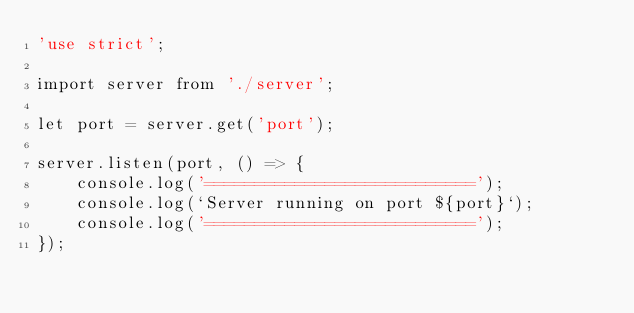Convert code to text. <code><loc_0><loc_0><loc_500><loc_500><_JavaScript_>'use strict';

import server from './server';

let port = server.get('port');

server.listen(port, () => {
    console.log('===========================');
    console.log(`Server running on port ${port}`);
    console.log('===========================');
});</code> 